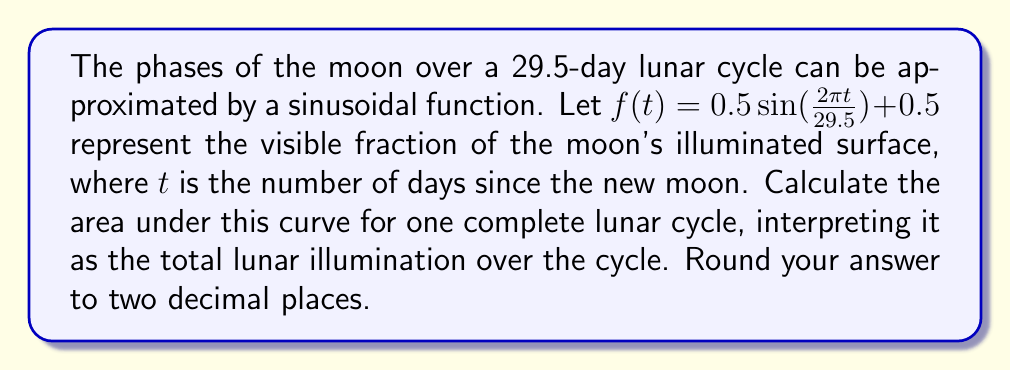Could you help me with this problem? To solve this problem, we need to integrate the function $f(t)$ over one complete lunar cycle (29.5 days). Let's break it down step-by-step:

1) The function is $f(t) = 0.5\sin(\frac{2\pi t}{29.5}) + 0.5$

2) We need to integrate this function from $t=0$ to $t=29.5$:

   $$\int_0^{29.5} (0.5\sin(\frac{2\pi t}{29.5}) + 0.5) dt$$

3) Let's split this into two integrals:

   $$0.5\int_0^{29.5} \sin(\frac{2\pi t}{29.5}) dt + 0.5\int_0^{29.5} dt$$

4) The second integral is straightforward:

   $$0.5\int_0^{29.5} dt = 0.5 \cdot 29.5 = 14.75$$

5) For the first integral, let's use the substitution $u = \frac{2\pi t}{29.5}$. Then $du = \frac{2\pi}{29.5} dt$, or $dt = \frac{29.5}{2\pi} du$

6) When $t=0$, $u=0$. When $t=29.5$, $u=2\pi$. So our integral becomes:

   $$0.5 \cdot \frac{29.5}{2\pi} \int_0^{2\pi} \sin(u) du$$

7) We know that $\int \sin(u) du = -\cos(u) + C$, so:

   $$0.5 \cdot \frac{29.5}{2\pi} [-\cos(u)]_0^{2\pi} = 0.5 \cdot \frac{29.5}{2\pi} [-\cos(2\pi) + \cos(0)] = 0$$

8) Adding this to our result from step 4:

   $$0 + 14.75 = 14.75$$

Therefore, the total area under the curve, representing the total lunar illumination over one cycle, is 14.75.
Answer: 14.75 